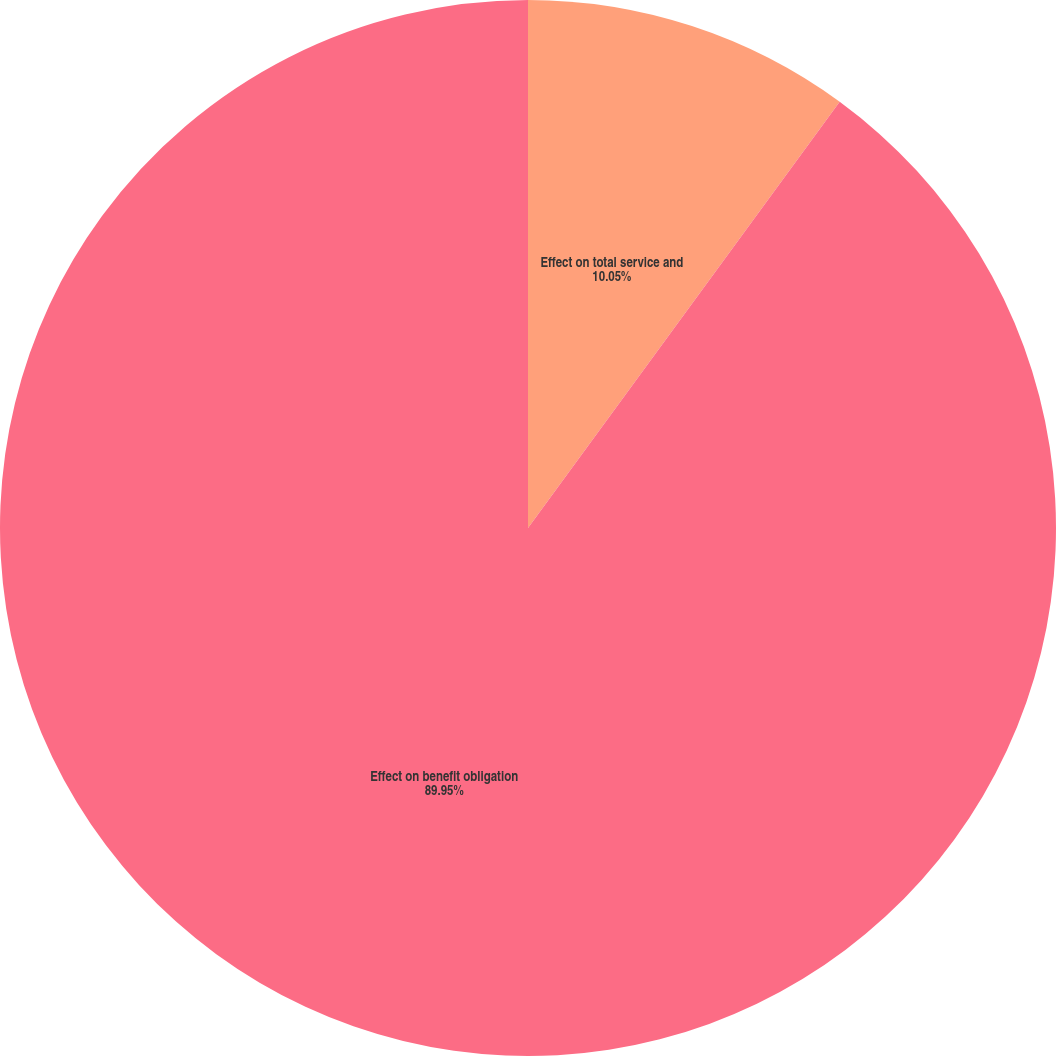<chart> <loc_0><loc_0><loc_500><loc_500><pie_chart><fcel>Effect on total service and<fcel>Effect on benefit obligation<nl><fcel>10.05%<fcel>89.95%<nl></chart> 